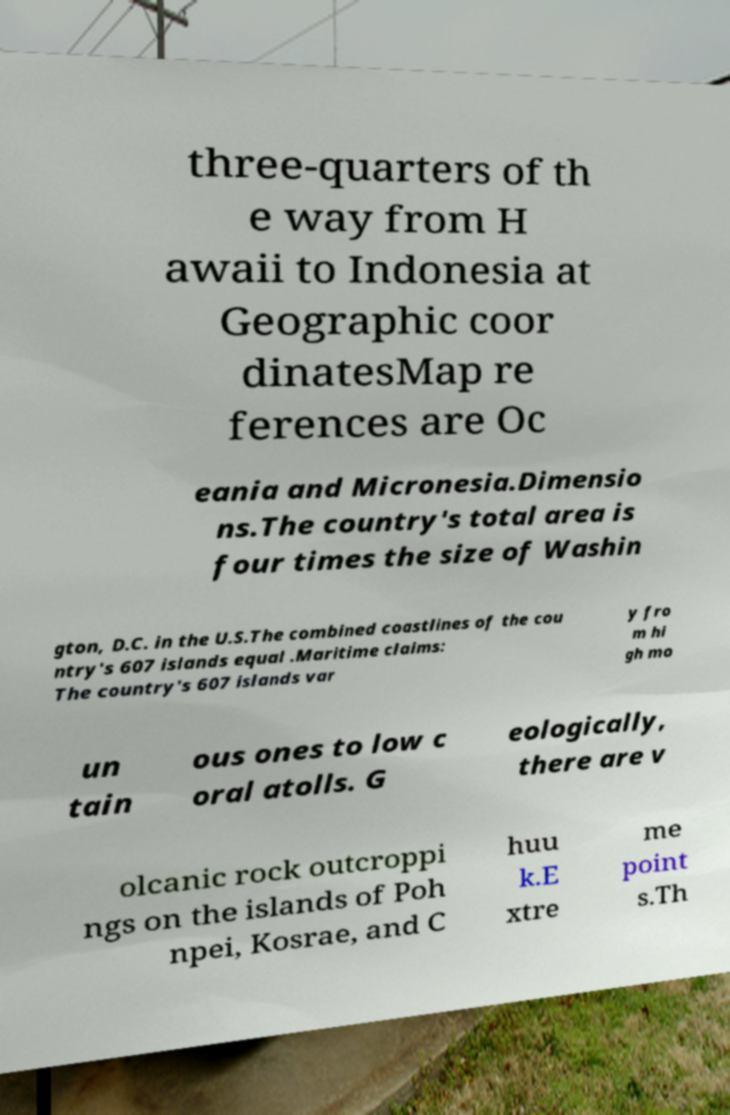What messages or text are displayed in this image? I need them in a readable, typed format. three-quarters of th e way from H awaii to Indonesia at Geographic coor dinatesMap re ferences are Oc eania and Micronesia.Dimensio ns.The country's total area is four times the size of Washin gton, D.C. in the U.S.The combined coastlines of the cou ntry's 607 islands equal .Maritime claims: The country's 607 islands var y fro m hi gh mo un tain ous ones to low c oral atolls. G eologically, there are v olcanic rock outcroppi ngs on the islands of Poh npei, Kosrae, and C huu k.E xtre me point s.Th 